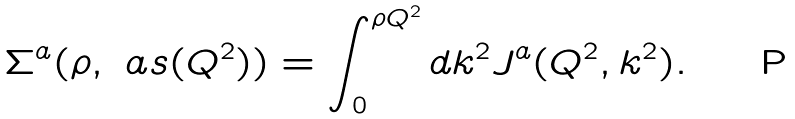<formula> <loc_0><loc_0><loc_500><loc_500>\Sigma ^ { a } ( \rho , \ a s ( Q ^ { 2 } ) ) = \int ^ { \rho Q ^ { 2 } } _ { 0 } d k ^ { 2 } J ^ { a } ( Q ^ { 2 } , k ^ { 2 } ) .</formula> 